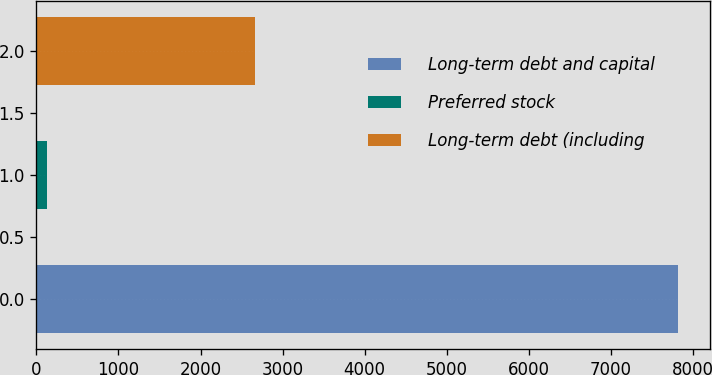Convert chart. <chart><loc_0><loc_0><loc_500><loc_500><bar_chart><fcel>Long-term debt and capital<fcel>Preferred stock<fcel>Long-term debt (including<nl><fcel>7814<fcel>125<fcel>2665<nl></chart> 